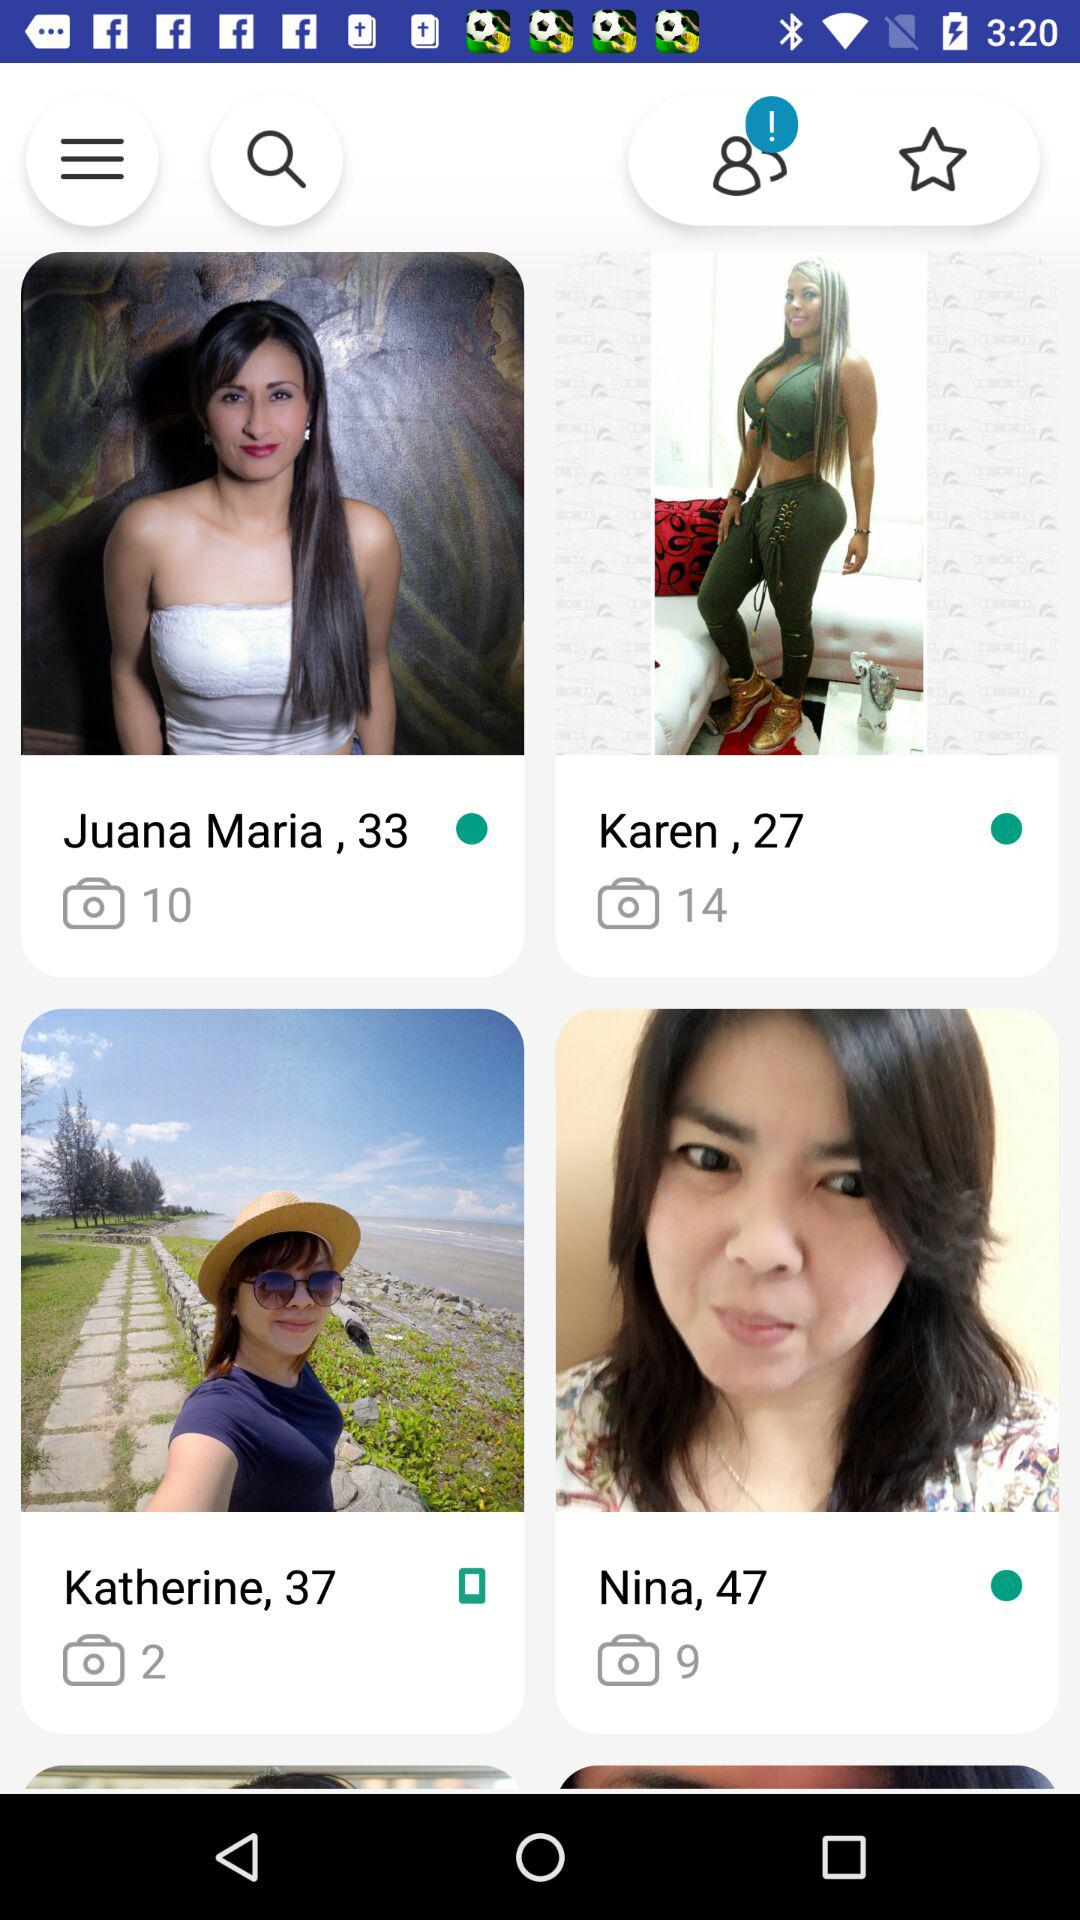How many photos are in Karen's gallery? There are 14 photos. 